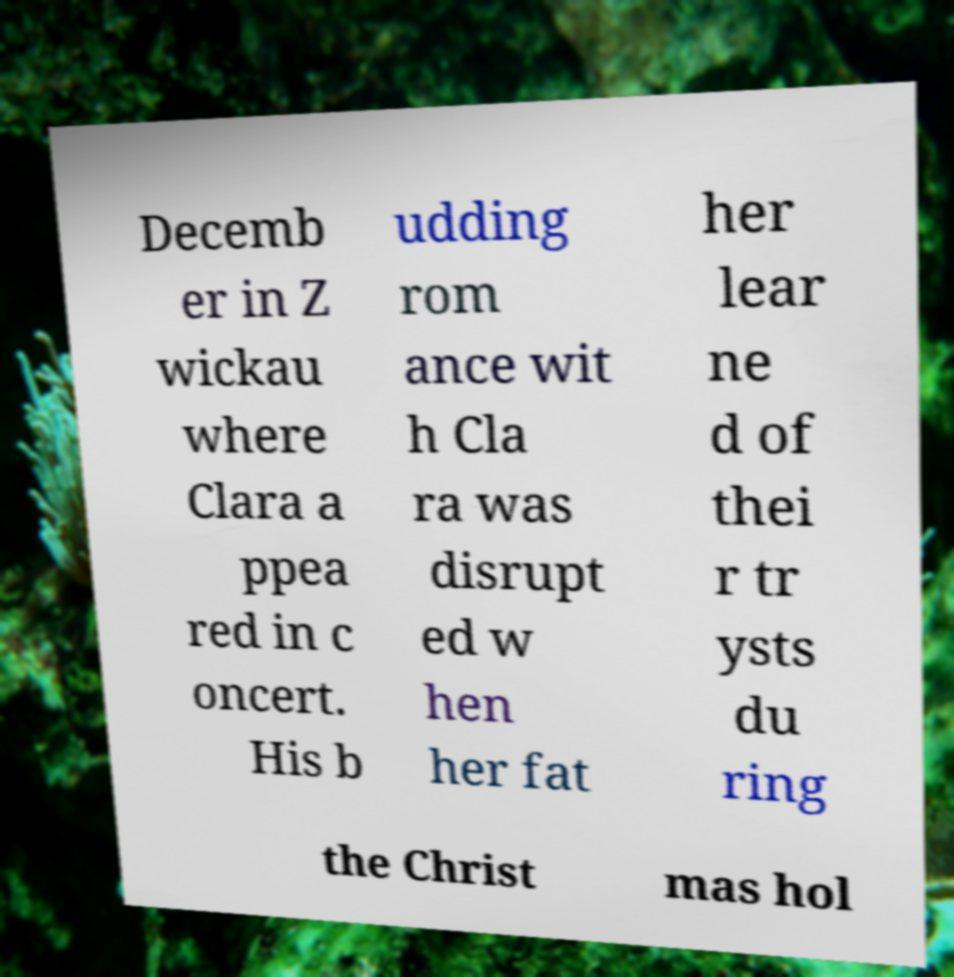Can you read and provide the text displayed in the image?This photo seems to have some interesting text. Can you extract and type it out for me? Decemb er in Z wickau where Clara a ppea red in c oncert. His b udding rom ance wit h Cla ra was disrupt ed w hen her fat her lear ne d of thei r tr ysts du ring the Christ mas hol 